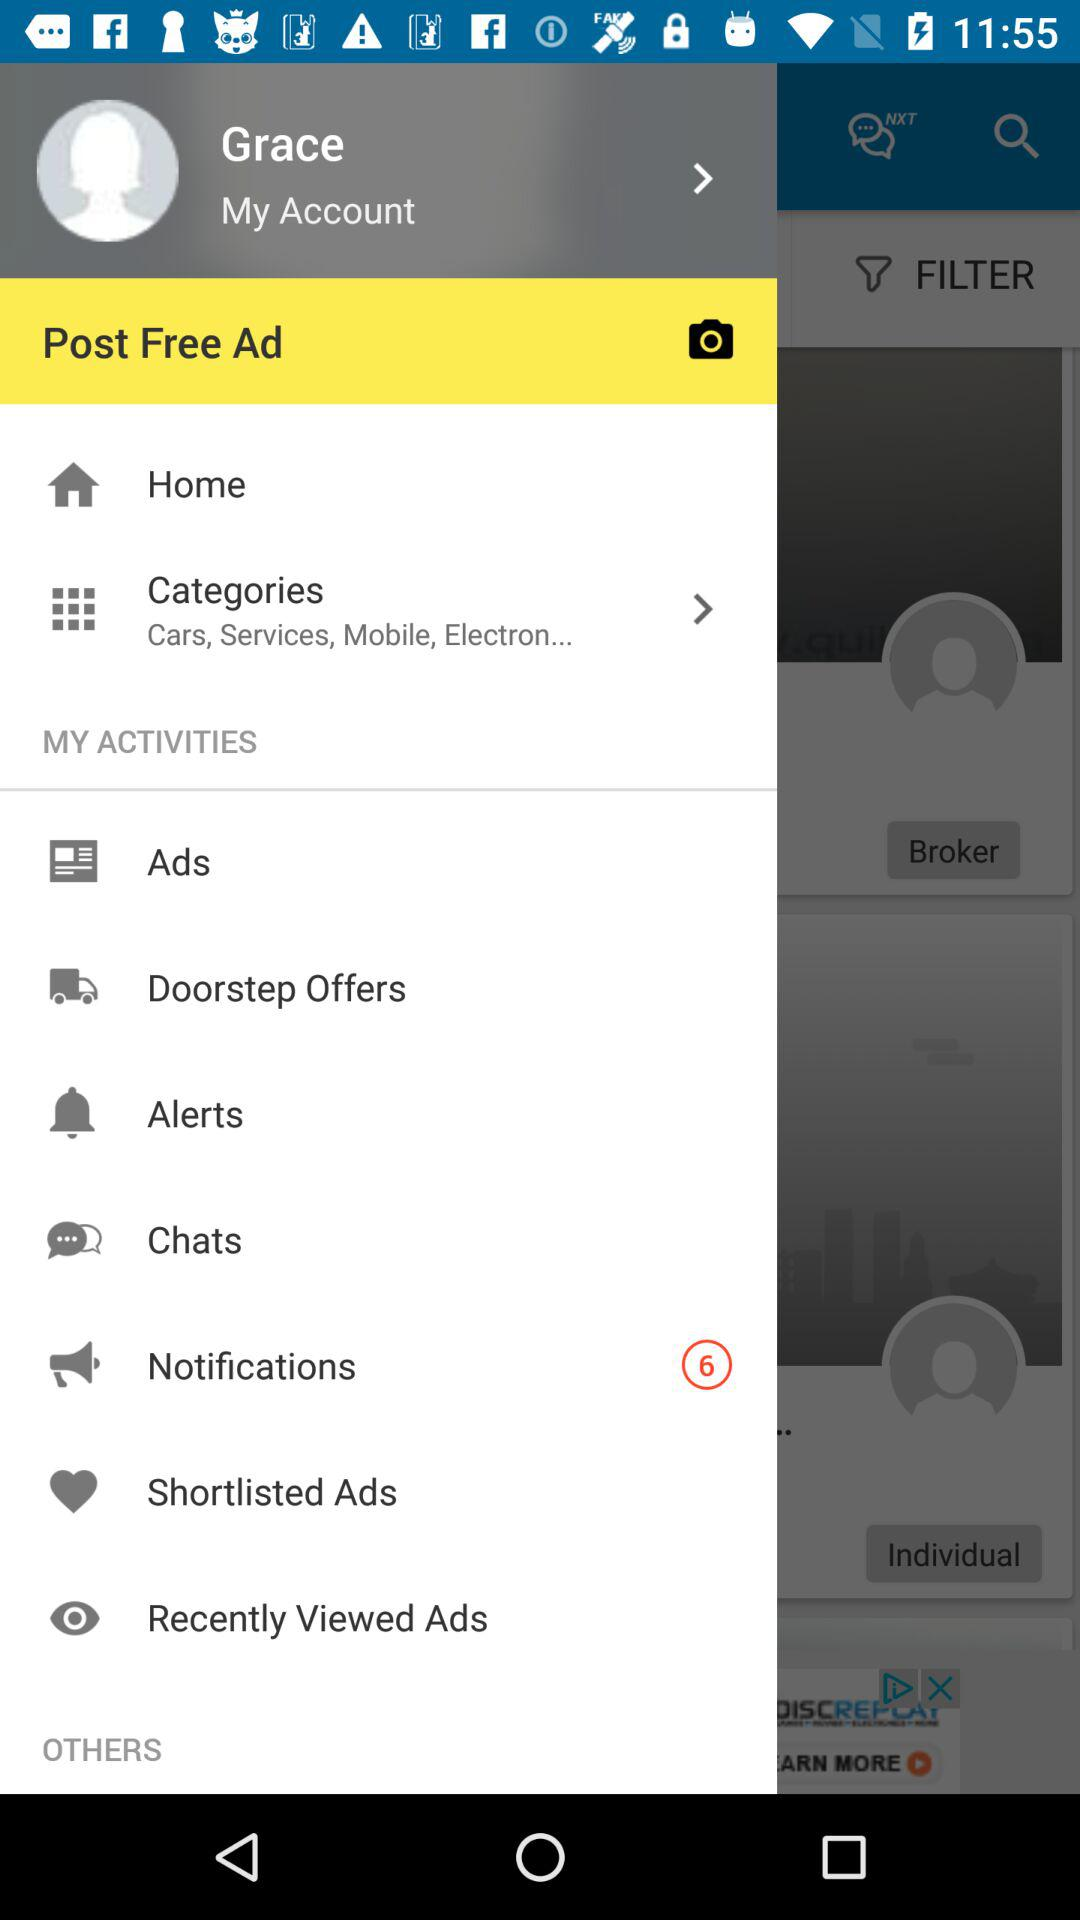What is the user name? The user name is Grace. 